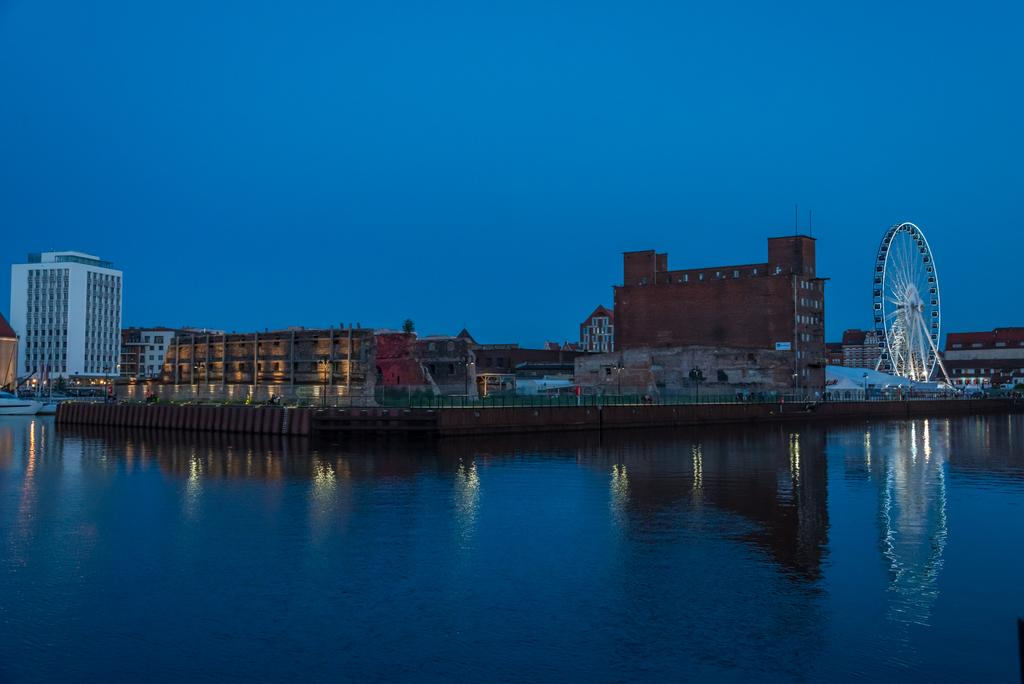What is the main element present in the image? There is water in the image. What else can be seen in the image besides the water? There are buildings and a joint wheel on the right side of the image. What is the color of the sky in the image? The sky is blue and visible at the top of the image. How many trees are visible in the image? There are no trees visible in the image; it features water, buildings, a joint wheel, and a blue sky. What is the rate of water flow in the image? There is no information about the rate of water flow in the image. 